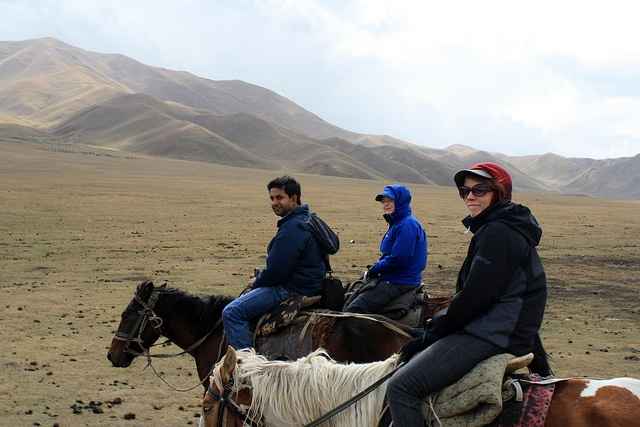Describe the objects in this image and their specific colors. I can see horse in lavender, black, gray, darkgray, and maroon tones, people in lavender, black, gray, maroon, and brown tones, horse in lavender, black, and gray tones, people in lavender, black, navy, gray, and darkblue tones, and people in lavender, black, navy, darkblue, and gray tones in this image. 